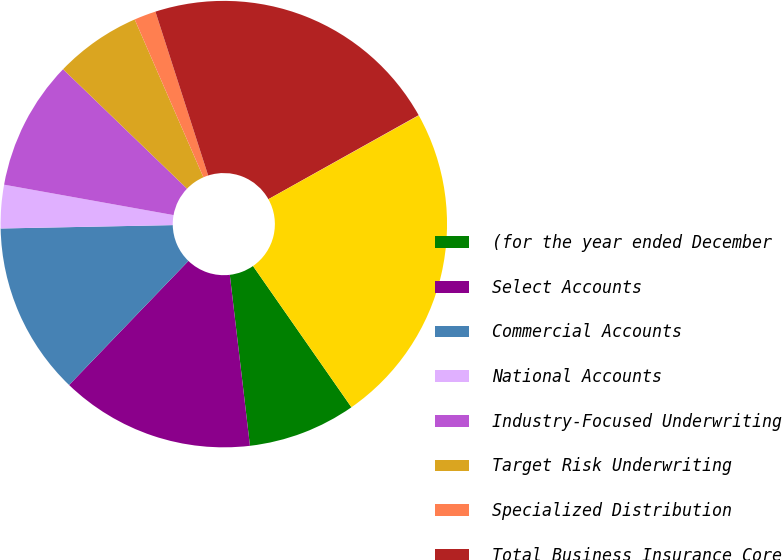Convert chart. <chart><loc_0><loc_0><loc_500><loc_500><pie_chart><fcel>(for the year ended December<fcel>Select Accounts<fcel>Commercial Accounts<fcel>National Accounts<fcel>Industry-Focused Underwriting<fcel>Target Risk Underwriting<fcel>Specialized Distribution<fcel>Total Business Insurance Core<fcel>Business Insurance Other<fcel>Total Business Insurance<nl><fcel>7.82%<fcel>14.06%<fcel>12.5%<fcel>3.14%<fcel>9.38%<fcel>6.26%<fcel>1.58%<fcel>21.85%<fcel>0.02%<fcel>23.41%<nl></chart> 